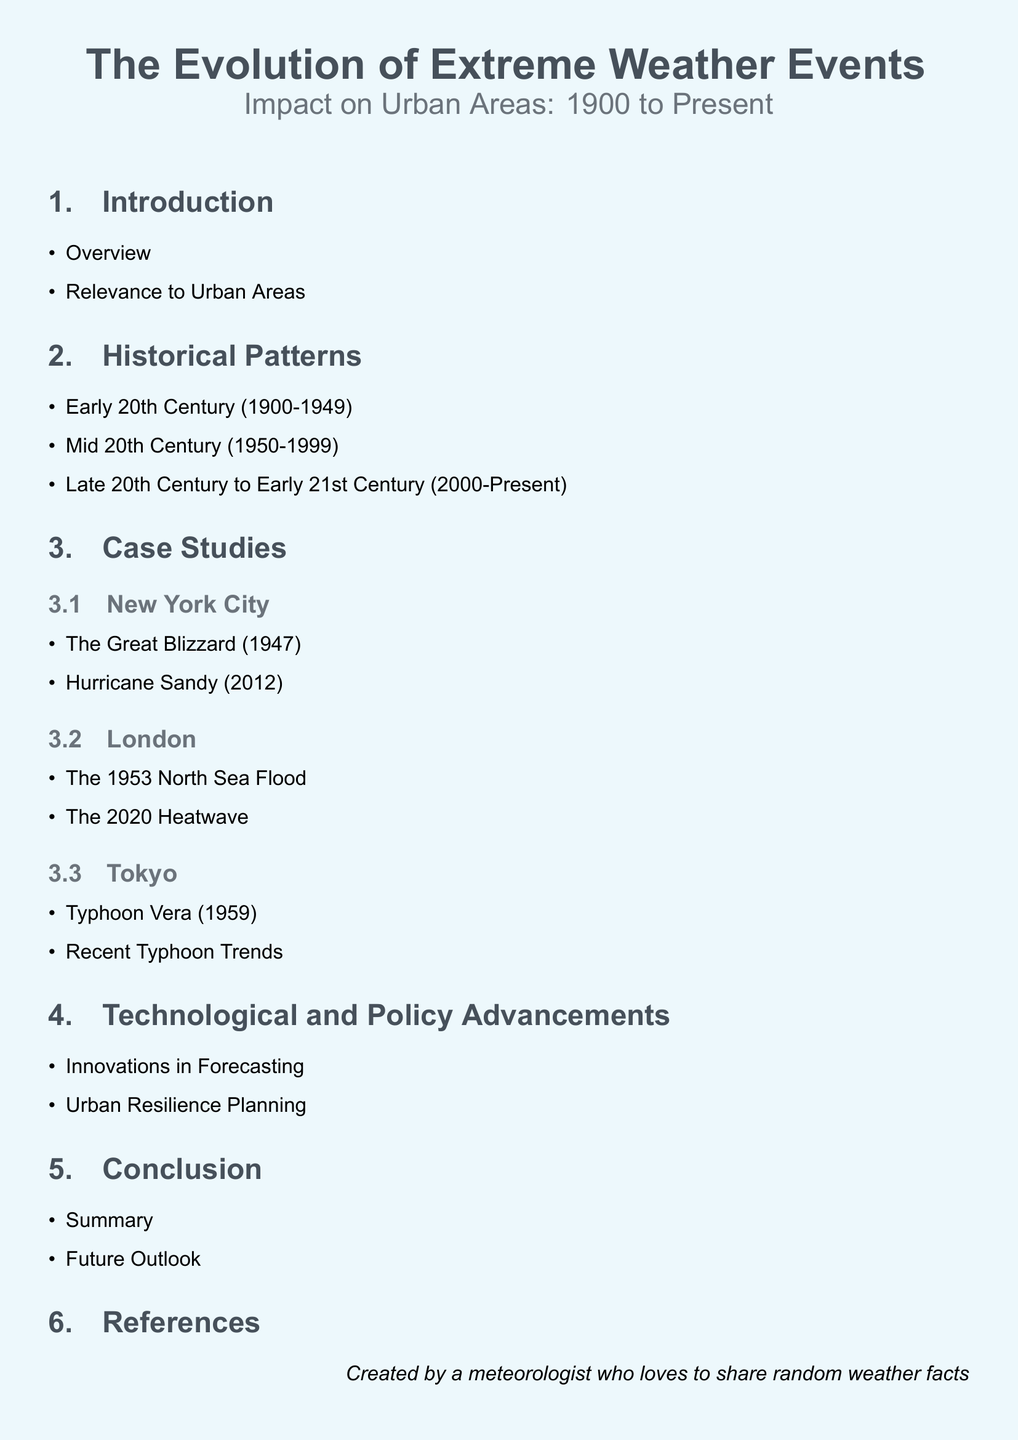What is the title of the document? The title is presented in the center at the top of the document, specified as "The Evolution of Extreme Weather Events."
Answer: The Evolution of Extreme Weather Events What does the document analyze chronologically? The document analyzes extreme weather events and their impact on urban areas, laid out in a chronological manner from 1900 to the present.
Answer: Extreme weather events What major cities are focused on in the document? Major cities mentioned in the document are specifically highlighted in the case studies, which include New York, London, and Tokyo.
Answer: New York, London, Tokyo What significant weather event occurred in New York City in 2012? The document lists Hurricane Sandy as a major weather event in New York City that occurred in 2012.
Answer: Hurricane Sandy What technological advancement is discussed in the document? The document mentions innovations in forecasting as a key technological advancement related to extreme weather events.
Answer: Innovations in Forecasting What major weather event impacted London in 1953? The 1953 North Sea Flood is identified in the document as a significant weather event affecting London.
Answer: The 1953 North Sea Flood What aspect does the conclusion section summarize? The conclusion section summarizes the document's overall findings and provides a future outlook on extreme weather and its impacts.
Answer: Summary Which weather phenomenon is mentioned in connection with Tokyo in 1959? Typhoon Vera is indicated as the significant weather event that impacted Tokyo in 1959.
Answer: Typhoon Vera What time period does the document cover for historical patterns? The document covers historical patterns of extreme weather events from 1900 to the present, divided into three main sections.
Answer: 1900 to present 